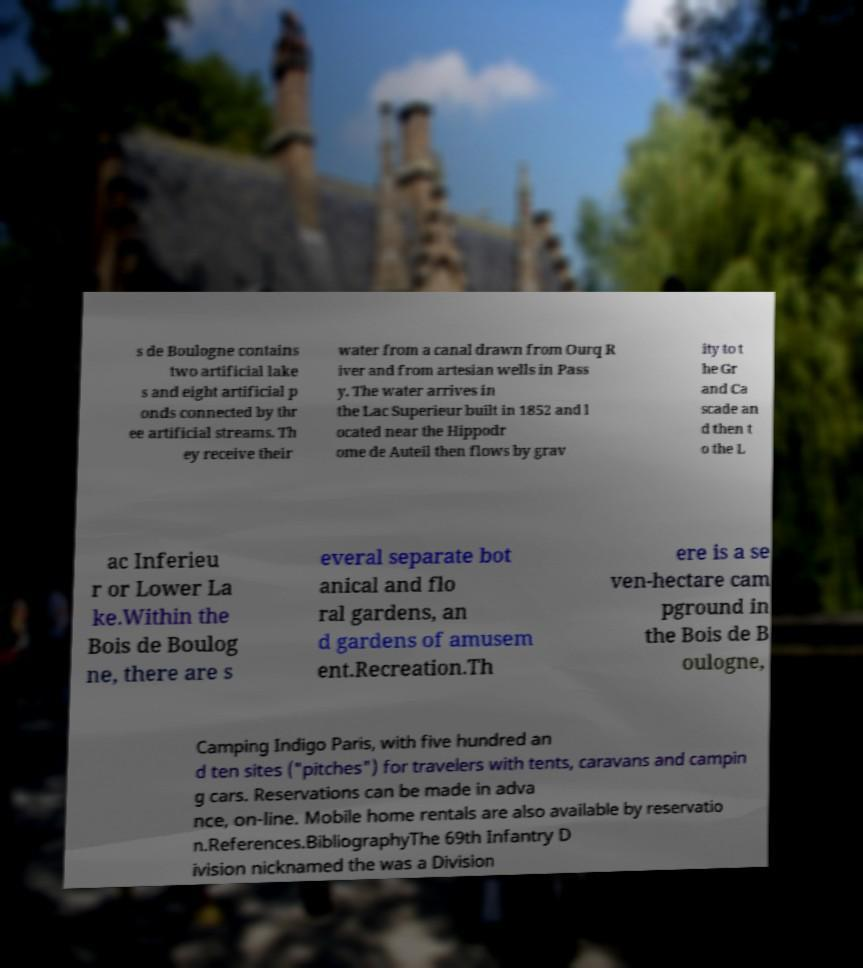Can you read and provide the text displayed in the image?This photo seems to have some interesting text. Can you extract and type it out for me? s de Boulogne contains two artificial lake s and eight artificial p onds connected by thr ee artificial streams. Th ey receive their water from a canal drawn from Ourq R iver and from artesian wells in Pass y. The water arrives in the Lac Superieur built in 1852 and l ocated near the Hippodr ome de Auteil then flows by grav ity to t he Gr and Ca scade an d then t o the L ac Inferieu r or Lower La ke.Within the Bois de Boulog ne, there are s everal separate bot anical and flo ral gardens, an d gardens of amusem ent.Recreation.Th ere is a se ven-hectare cam pground in the Bois de B oulogne, Camping Indigo Paris, with five hundred an d ten sites ("pitches") for travelers with tents, caravans and campin g cars. Reservations can be made in adva nce, on-line. Mobile home rentals are also available by reservatio n.References.BibliographyThe 69th Infantry D ivision nicknamed the was a Division 